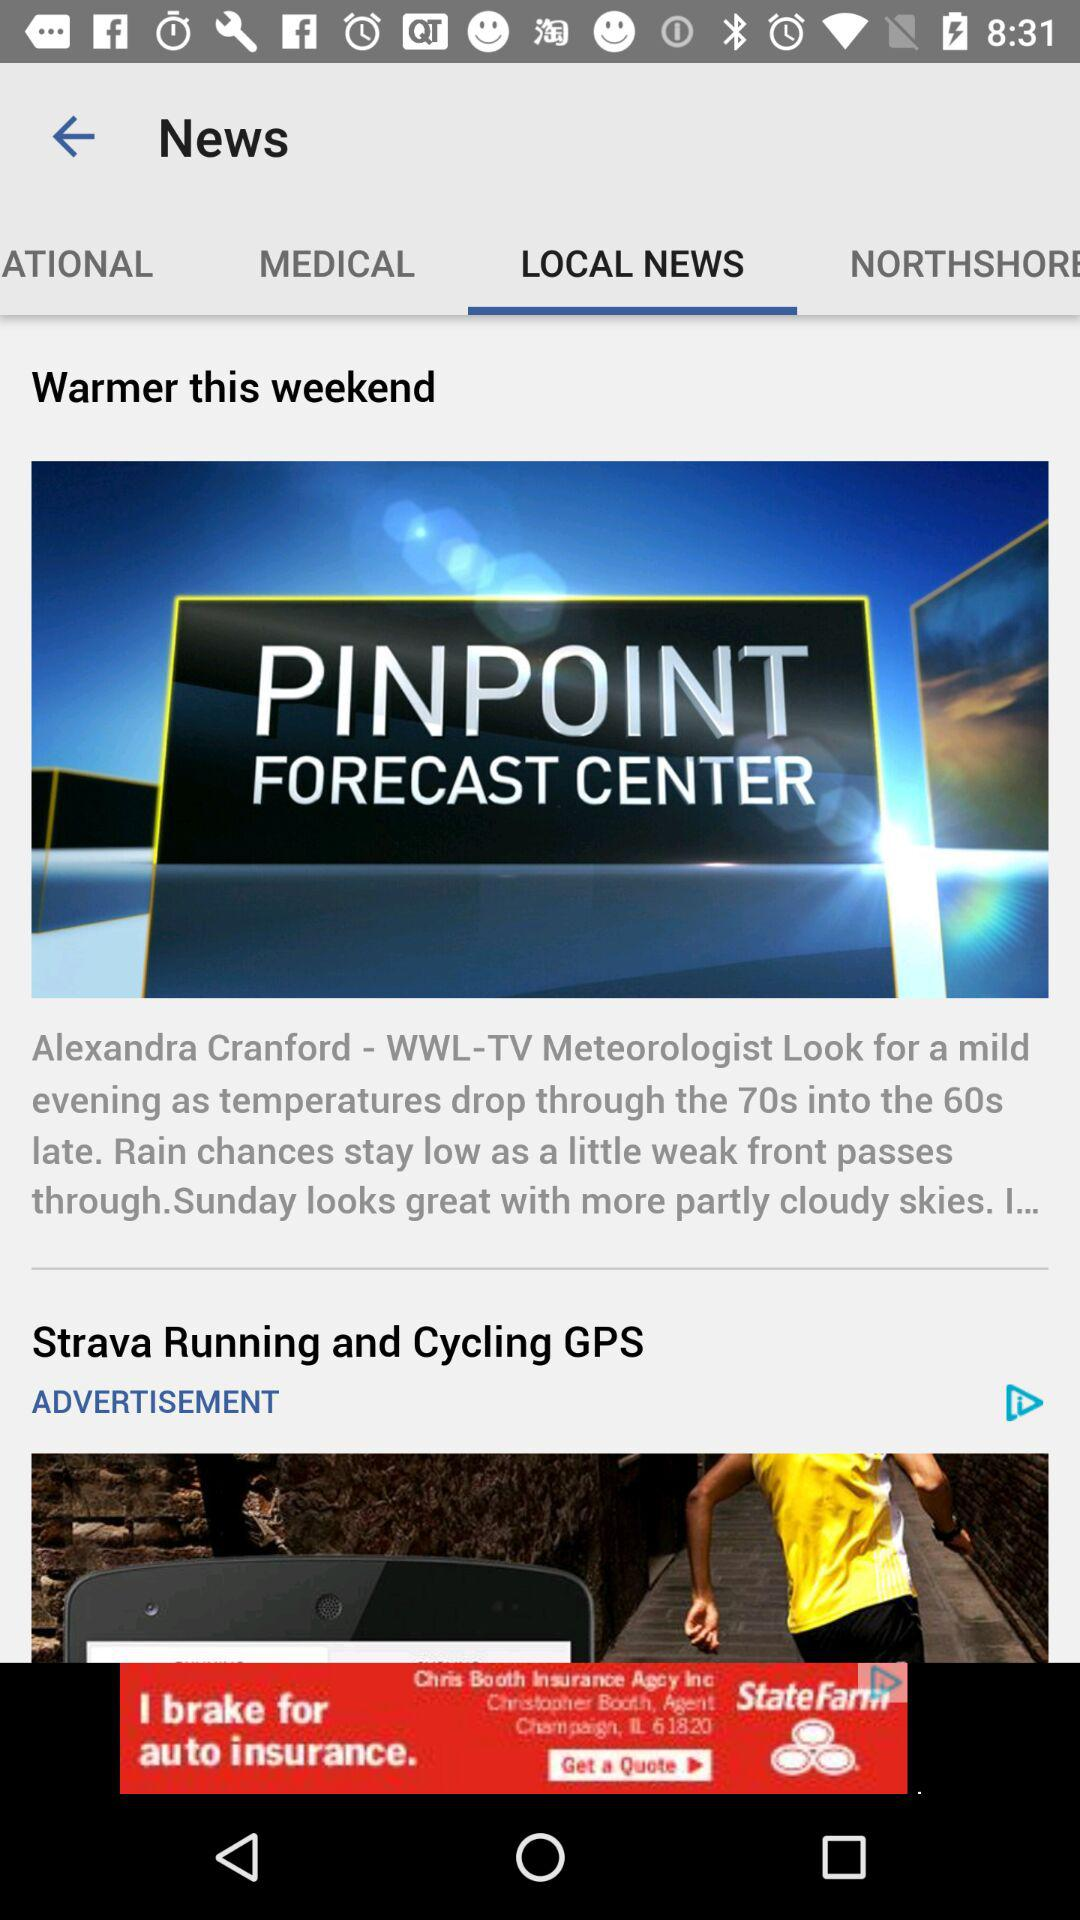How is the weekend weather? The weekend weather is "Warmer". 